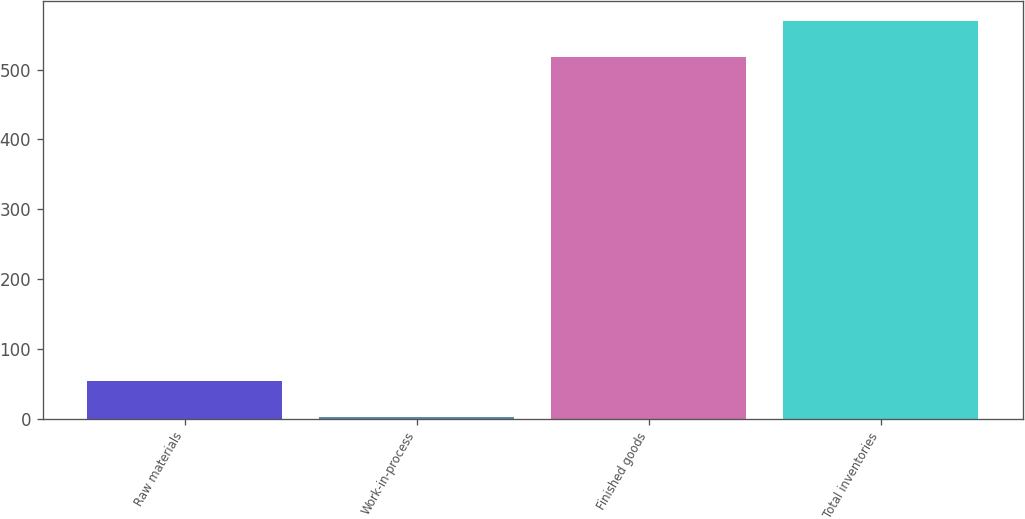Convert chart to OTSL. <chart><loc_0><loc_0><loc_500><loc_500><bar_chart><fcel>Raw materials<fcel>Work-in-process<fcel>Finished goods<fcel>Total inventories<nl><fcel>54.04<fcel>1.7<fcel>518<fcel>570.34<nl></chart> 